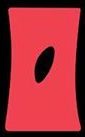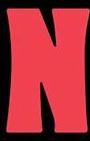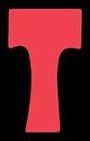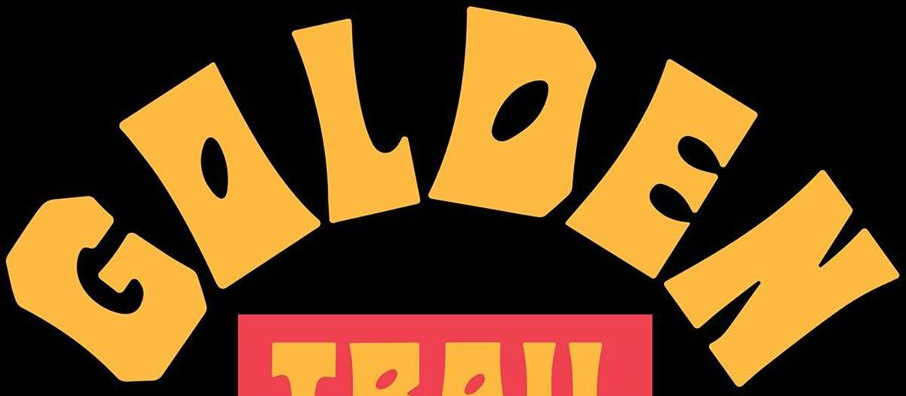Transcribe the words shown in these images in order, separated by a semicolon. O; N; T; GOLDEN 